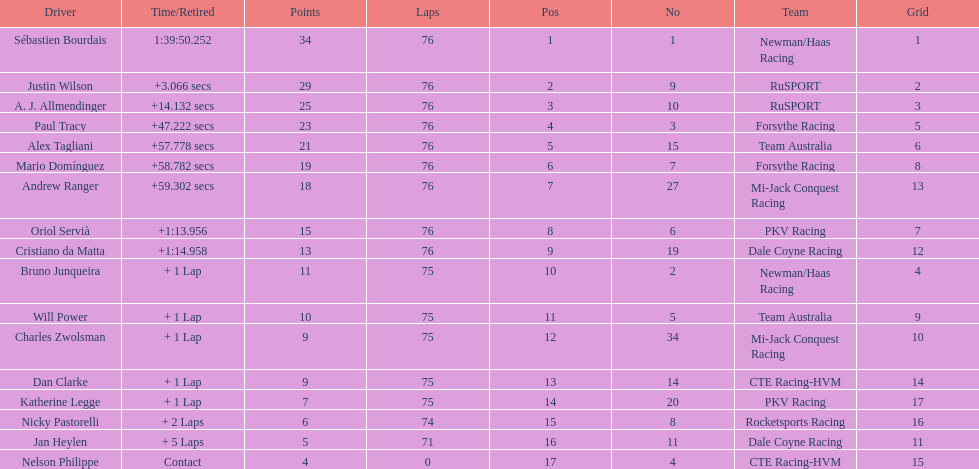What is the total point difference between the driver who received the most points and the driver who received the least? 30. Parse the table in full. {'header': ['Driver', 'Time/Retired', 'Points', 'Laps', 'Pos', 'No', 'Team', 'Grid'], 'rows': [['Sébastien Bourdais', '1:39:50.252', '34', '76', '1', '1', 'Newman/Haas Racing', '1'], ['Justin Wilson', '+3.066 secs', '29', '76', '2', '9', 'RuSPORT', '2'], ['A. J. Allmendinger', '+14.132 secs', '25', '76', '3', '10', 'RuSPORT', '3'], ['Paul Tracy', '+47.222 secs', '23', '76', '4', '3', 'Forsythe Racing', '5'], ['Alex Tagliani', '+57.778 secs', '21', '76', '5', '15', 'Team Australia', '6'], ['Mario Domínguez', '+58.782 secs', '19', '76', '6', '7', 'Forsythe Racing', '8'], ['Andrew Ranger', '+59.302 secs', '18', '76', '7', '27', 'Mi-Jack Conquest Racing', '13'], ['Oriol Servià', '+1:13.956', '15', '76', '8', '6', 'PKV Racing', '7'], ['Cristiano da Matta', '+1:14.958', '13', '76', '9', '19', 'Dale Coyne Racing', '12'], ['Bruno Junqueira', '+ 1 Lap', '11', '75', '10', '2', 'Newman/Haas Racing', '4'], ['Will Power', '+ 1 Lap', '10', '75', '11', '5', 'Team Australia', '9'], ['Charles Zwolsman', '+ 1 Lap', '9', '75', '12', '34', 'Mi-Jack Conquest Racing', '10'], ['Dan Clarke', '+ 1 Lap', '9', '75', '13', '14', 'CTE Racing-HVM', '14'], ['Katherine Legge', '+ 1 Lap', '7', '75', '14', '20', 'PKV Racing', '17'], ['Nicky Pastorelli', '+ 2 Laps', '6', '74', '15', '8', 'Rocketsports Racing', '16'], ['Jan Heylen', '+ 5 Laps', '5', '71', '16', '11', 'Dale Coyne Racing', '11'], ['Nelson Philippe', 'Contact', '4', '0', '17', '4', 'CTE Racing-HVM', '15']]} 